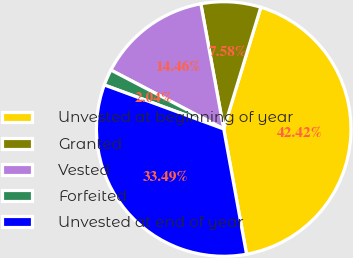<chart> <loc_0><loc_0><loc_500><loc_500><pie_chart><fcel>Unvested at beginning of year<fcel>Granted<fcel>Vested<fcel>Forfeited<fcel>Unvested at end of year<nl><fcel>42.42%<fcel>7.58%<fcel>14.46%<fcel>2.04%<fcel>33.49%<nl></chart> 